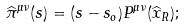Convert formula to latex. <formula><loc_0><loc_0><loc_500><loc_500>\widehat { \pi } ^ { \mu \nu } ( s ) = ( s - s _ { o } ) P ^ { \mu \nu } ( \widehat { x } _ { R } ) ;</formula> 